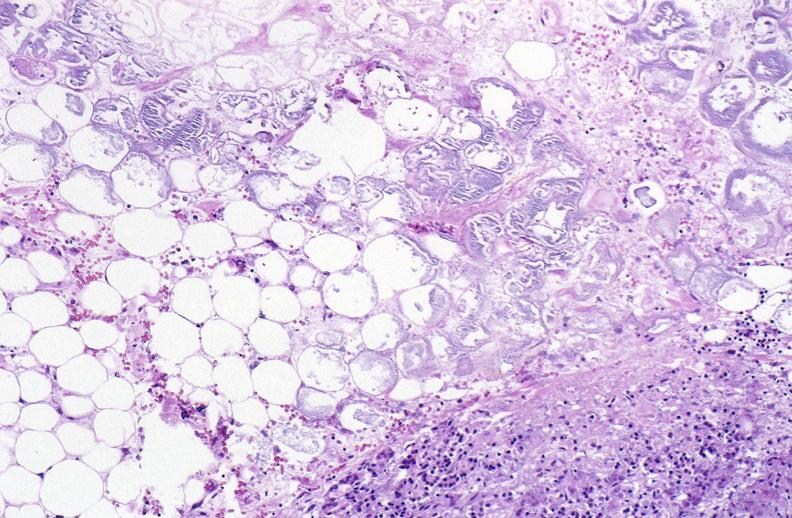does breast show pancreatic fat necrosis?
Answer the question using a single word or phrase. No 